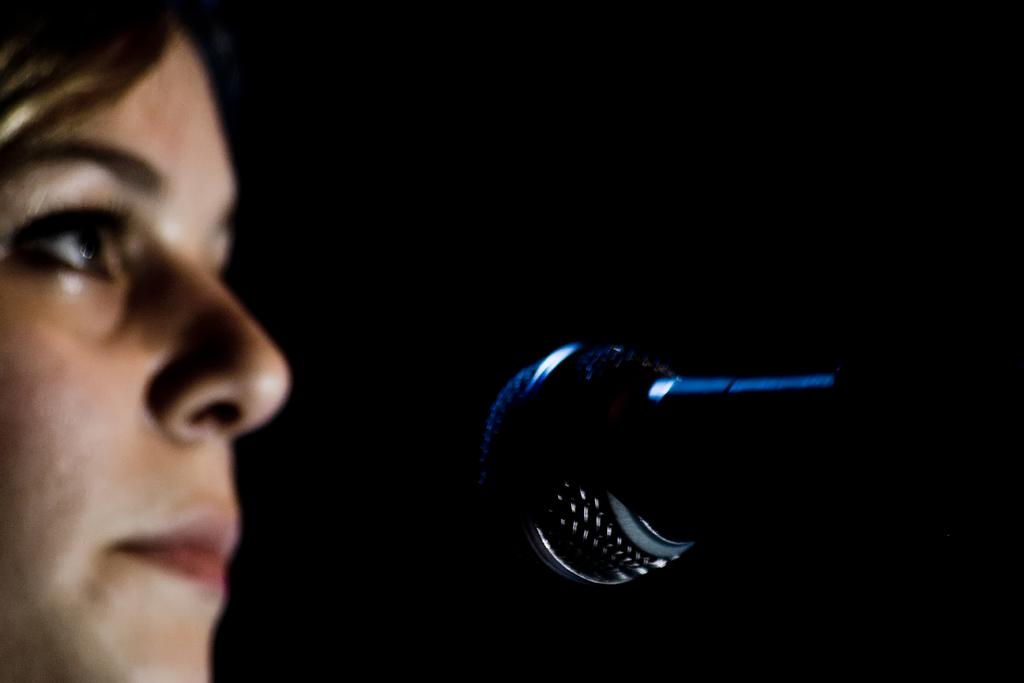What is located on the left side of the image? There is a woman's face on the left side of the image. What object is in the center of the image? There is a microphone in the center of the image. What color is the background of the image? The background of the image is black. Can you see any horses in the image? No, there are no horses present in the image. How does the coastline look in the image? There is no coastline visible in the image; it features a woman's face and a microphone against a black background. 